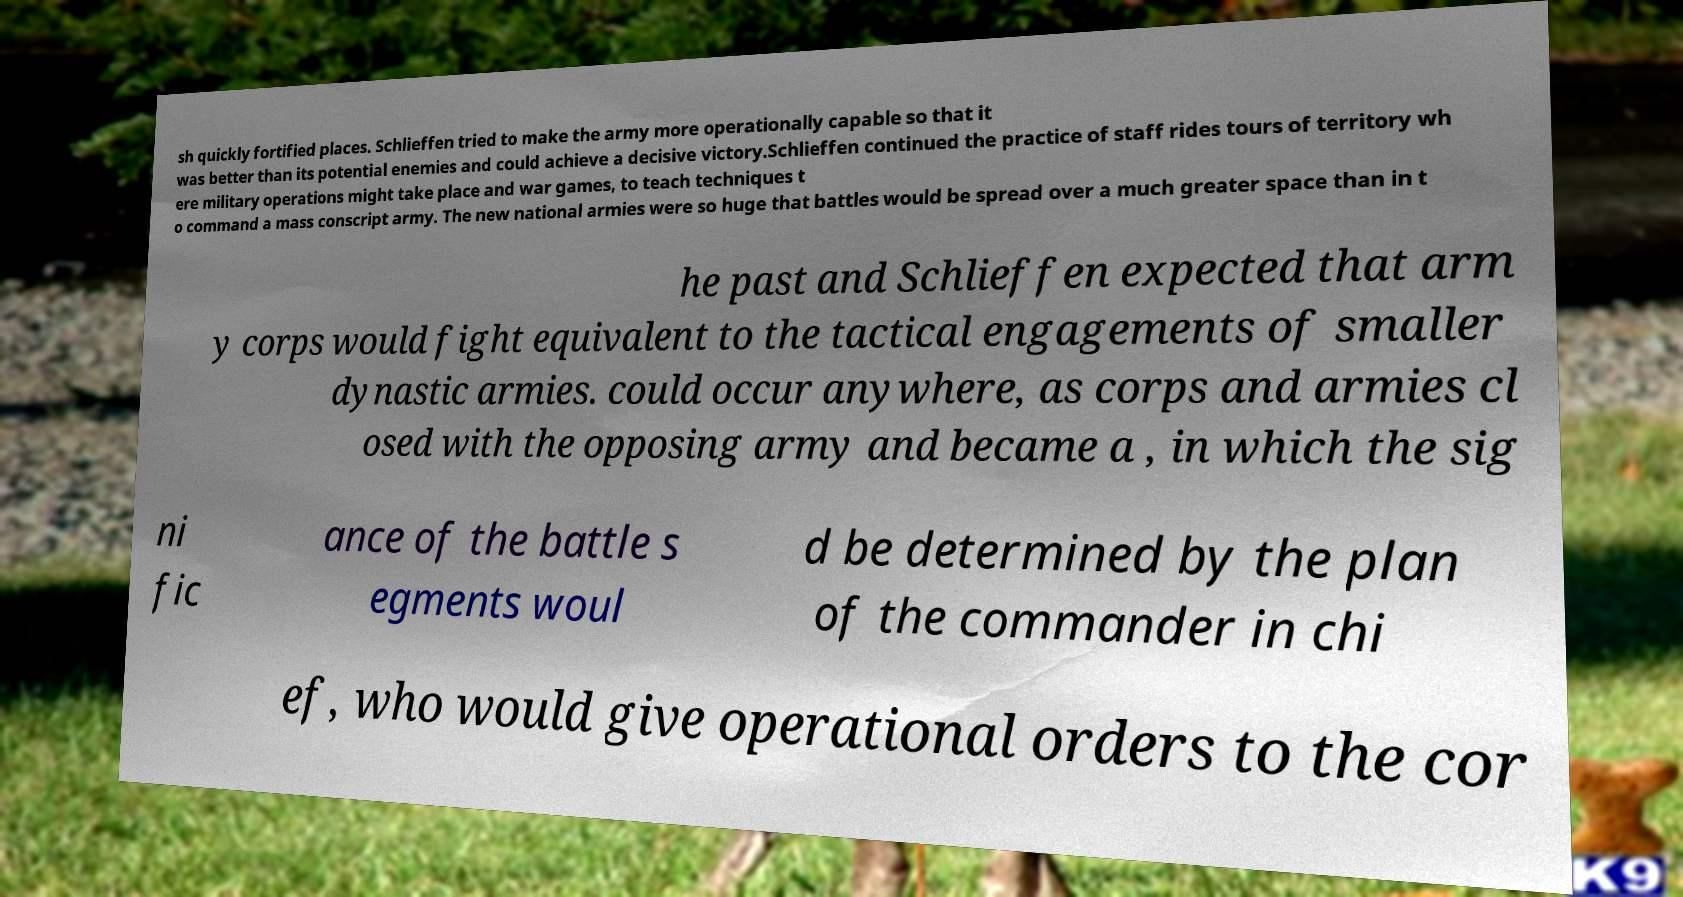For documentation purposes, I need the text within this image transcribed. Could you provide that? sh quickly fortified places. Schlieffen tried to make the army more operationally capable so that it was better than its potential enemies and could achieve a decisive victory.Schlieffen continued the practice of staff rides tours of territory wh ere military operations might take place and war games, to teach techniques t o command a mass conscript army. The new national armies were so huge that battles would be spread over a much greater space than in t he past and Schlieffen expected that arm y corps would fight equivalent to the tactical engagements of smaller dynastic armies. could occur anywhere, as corps and armies cl osed with the opposing army and became a , in which the sig ni fic ance of the battle s egments woul d be determined by the plan of the commander in chi ef, who would give operational orders to the cor 